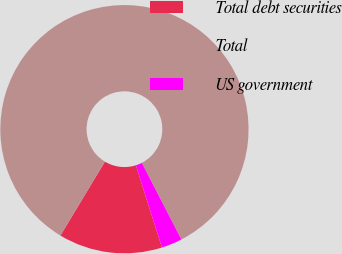Convert chart to OTSL. <chart><loc_0><loc_0><loc_500><loc_500><pie_chart><fcel>Total debt securities<fcel>Total<fcel>US government<nl><fcel>13.51%<fcel>83.78%<fcel>2.7%<nl></chart> 